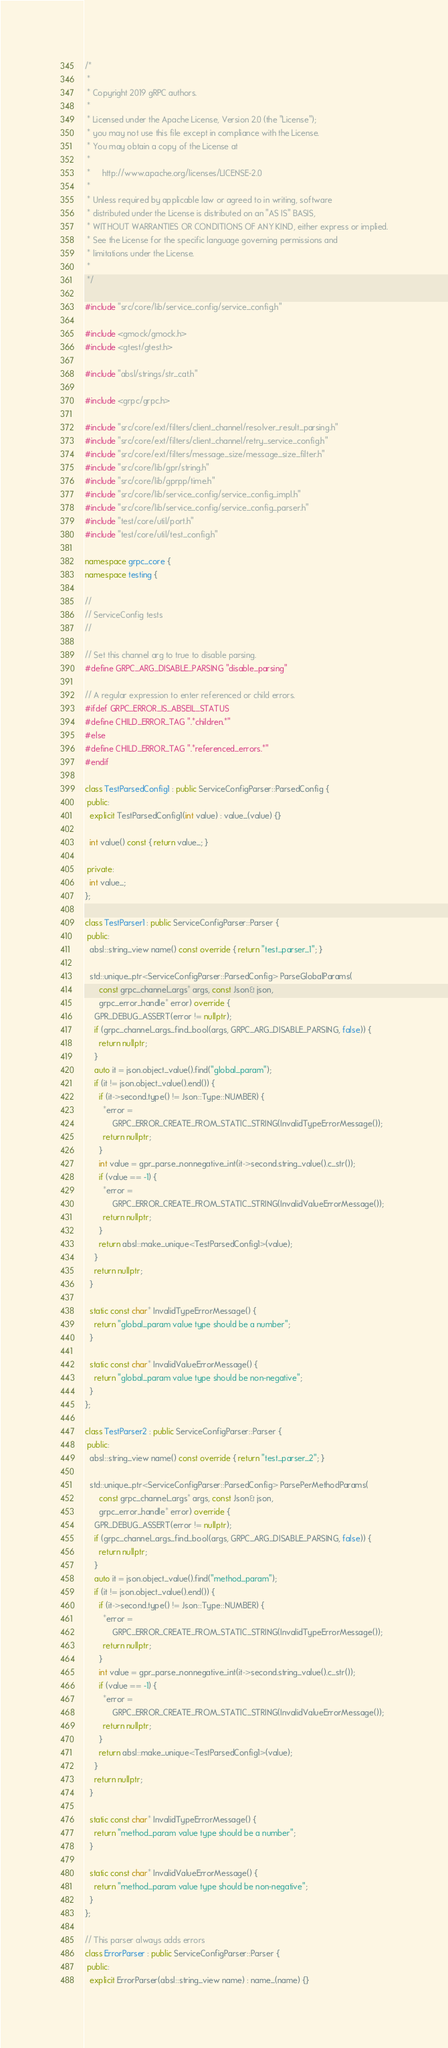<code> <loc_0><loc_0><loc_500><loc_500><_C++_>/*
 *
 * Copyright 2019 gRPC authors.
 *
 * Licensed under the Apache License, Version 2.0 (the "License");
 * you may not use this file except in compliance with the License.
 * You may obtain a copy of the License at
 *
 *     http://www.apache.org/licenses/LICENSE-2.0
 *
 * Unless required by applicable law or agreed to in writing, software
 * distributed under the License is distributed on an "AS IS" BASIS,
 * WITHOUT WARRANTIES OR CONDITIONS OF ANY KIND, either express or implied.
 * See the License for the specific language governing permissions and
 * limitations under the License.
 *
 */

#include "src/core/lib/service_config/service_config.h"

#include <gmock/gmock.h>
#include <gtest/gtest.h>

#include "absl/strings/str_cat.h"

#include <grpc/grpc.h>

#include "src/core/ext/filters/client_channel/resolver_result_parsing.h"
#include "src/core/ext/filters/client_channel/retry_service_config.h"
#include "src/core/ext/filters/message_size/message_size_filter.h"
#include "src/core/lib/gpr/string.h"
#include "src/core/lib/gprpp/time.h"
#include "src/core/lib/service_config/service_config_impl.h"
#include "src/core/lib/service_config/service_config_parser.h"
#include "test/core/util/port.h"
#include "test/core/util/test_config.h"

namespace grpc_core {
namespace testing {

//
// ServiceConfig tests
//

// Set this channel arg to true to disable parsing.
#define GRPC_ARG_DISABLE_PARSING "disable_parsing"

// A regular expression to enter referenced or child errors.
#ifdef GRPC_ERROR_IS_ABSEIL_STATUS
#define CHILD_ERROR_TAG ".*children.*"
#else
#define CHILD_ERROR_TAG ".*referenced_errors.*"
#endif

class TestParsedConfig1 : public ServiceConfigParser::ParsedConfig {
 public:
  explicit TestParsedConfig1(int value) : value_(value) {}

  int value() const { return value_; }

 private:
  int value_;
};

class TestParser1 : public ServiceConfigParser::Parser {
 public:
  absl::string_view name() const override { return "test_parser_1"; }

  std::unique_ptr<ServiceConfigParser::ParsedConfig> ParseGlobalParams(
      const grpc_channel_args* args, const Json& json,
      grpc_error_handle* error) override {
    GPR_DEBUG_ASSERT(error != nullptr);
    if (grpc_channel_args_find_bool(args, GRPC_ARG_DISABLE_PARSING, false)) {
      return nullptr;
    }
    auto it = json.object_value().find("global_param");
    if (it != json.object_value().end()) {
      if (it->second.type() != Json::Type::NUMBER) {
        *error =
            GRPC_ERROR_CREATE_FROM_STATIC_STRING(InvalidTypeErrorMessage());
        return nullptr;
      }
      int value = gpr_parse_nonnegative_int(it->second.string_value().c_str());
      if (value == -1) {
        *error =
            GRPC_ERROR_CREATE_FROM_STATIC_STRING(InvalidValueErrorMessage());
        return nullptr;
      }
      return absl::make_unique<TestParsedConfig1>(value);
    }
    return nullptr;
  }

  static const char* InvalidTypeErrorMessage() {
    return "global_param value type should be a number";
  }

  static const char* InvalidValueErrorMessage() {
    return "global_param value type should be non-negative";
  }
};

class TestParser2 : public ServiceConfigParser::Parser {
 public:
  absl::string_view name() const override { return "test_parser_2"; }

  std::unique_ptr<ServiceConfigParser::ParsedConfig> ParsePerMethodParams(
      const grpc_channel_args* args, const Json& json,
      grpc_error_handle* error) override {
    GPR_DEBUG_ASSERT(error != nullptr);
    if (grpc_channel_args_find_bool(args, GRPC_ARG_DISABLE_PARSING, false)) {
      return nullptr;
    }
    auto it = json.object_value().find("method_param");
    if (it != json.object_value().end()) {
      if (it->second.type() != Json::Type::NUMBER) {
        *error =
            GRPC_ERROR_CREATE_FROM_STATIC_STRING(InvalidTypeErrorMessage());
        return nullptr;
      }
      int value = gpr_parse_nonnegative_int(it->second.string_value().c_str());
      if (value == -1) {
        *error =
            GRPC_ERROR_CREATE_FROM_STATIC_STRING(InvalidValueErrorMessage());
        return nullptr;
      }
      return absl::make_unique<TestParsedConfig1>(value);
    }
    return nullptr;
  }

  static const char* InvalidTypeErrorMessage() {
    return "method_param value type should be a number";
  }

  static const char* InvalidValueErrorMessage() {
    return "method_param value type should be non-negative";
  }
};

// This parser always adds errors
class ErrorParser : public ServiceConfigParser::Parser {
 public:
  explicit ErrorParser(absl::string_view name) : name_(name) {}
</code> 